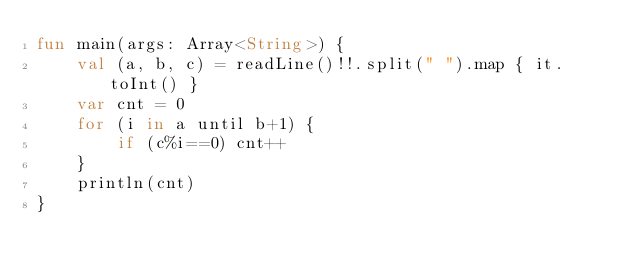Convert code to text. <code><loc_0><loc_0><loc_500><loc_500><_Kotlin_>fun main(args: Array<String>) {
    val (a, b, c) = readLine()!!.split(" ").map { it.toInt() }
    var cnt = 0
    for (i in a until b+1) {
        if (c%i==0) cnt++
    }
    println(cnt)
}
</code> 